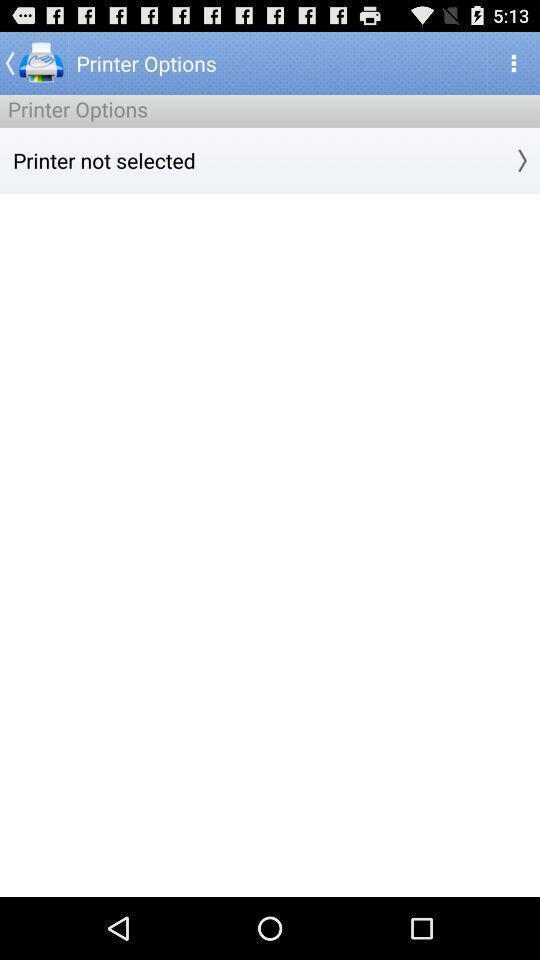What details can you identify in this image? Page showing to print directly from an app. 